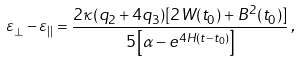Convert formula to latex. <formula><loc_0><loc_0><loc_500><loc_500>\varepsilon _ { \bot } - \varepsilon _ { | | } = \frac { 2 \kappa ( q _ { 2 } + 4 q _ { 3 } ) [ 2 W ( t _ { 0 } ) + B ^ { 2 } ( t _ { 0 } ) ] } { 5 \left [ \alpha - e ^ { 4 H ( t - t _ { 0 } ) } \right ] } \, ,</formula> 